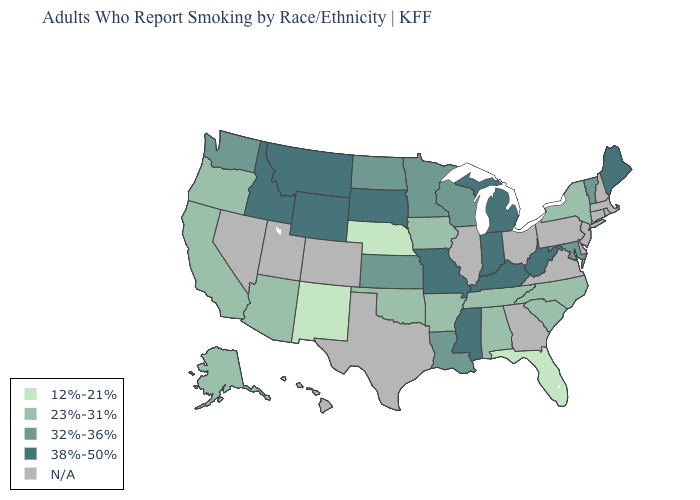Name the states that have a value in the range 32%-36%?
Quick response, please. Kansas, Louisiana, Maryland, Minnesota, North Dakota, Vermont, Washington, Wisconsin. What is the value of South Dakota?
Quick response, please. 38%-50%. Name the states that have a value in the range 12%-21%?
Quick response, please. Florida, Nebraska, New Mexico. Does Maine have the lowest value in the Northeast?
Write a very short answer. No. How many symbols are there in the legend?
Short answer required. 5. What is the value of South Carolina?
Be succinct. 23%-31%. What is the highest value in states that border Arizona?
Concise answer only. 23%-31%. Does the first symbol in the legend represent the smallest category?
Quick response, please. Yes. Among the states that border Texas , which have the lowest value?
Write a very short answer. New Mexico. Name the states that have a value in the range 12%-21%?
Be succinct. Florida, Nebraska, New Mexico. What is the value of Michigan?
Answer briefly. 38%-50%. Name the states that have a value in the range 12%-21%?
Keep it brief. Florida, Nebraska, New Mexico. What is the value of Iowa?
Quick response, please. 23%-31%. 